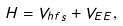Convert formula to latex. <formula><loc_0><loc_0><loc_500><loc_500>H = V _ { h f s } + V _ { E E } ,</formula> 